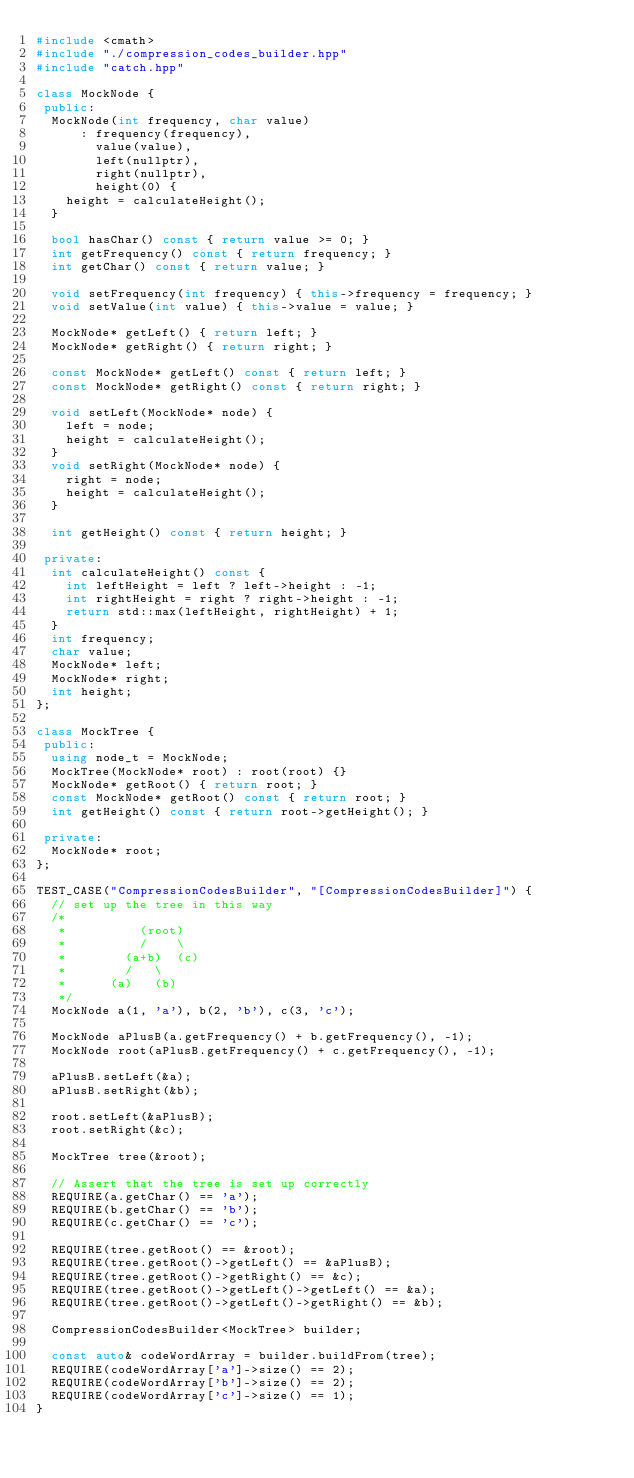<code> <loc_0><loc_0><loc_500><loc_500><_C++_>#include <cmath>
#include "./compression_codes_builder.hpp"
#include "catch.hpp"

class MockNode {
 public:
  MockNode(int frequency, char value)
      : frequency(frequency),
        value(value),
        left(nullptr),
        right(nullptr),
        height(0) {
    height = calculateHeight();
  }

  bool hasChar() const { return value >= 0; }
  int getFrequency() const { return frequency; }
  int getChar() const { return value; }

  void setFrequency(int frequency) { this->frequency = frequency; }
  void setValue(int value) { this->value = value; }

  MockNode* getLeft() { return left; }
  MockNode* getRight() { return right; }

  const MockNode* getLeft() const { return left; }
  const MockNode* getRight() const { return right; }

  void setLeft(MockNode* node) {
    left = node;
    height = calculateHeight();
  }
  void setRight(MockNode* node) {
    right = node;
    height = calculateHeight();
  }

  int getHeight() const { return height; }

 private:
  int calculateHeight() const {
    int leftHeight = left ? left->height : -1;
    int rightHeight = right ? right->height : -1;
    return std::max(leftHeight, rightHeight) + 1;
  }
  int frequency;
  char value;
  MockNode* left;
  MockNode* right;
  int height;
};

class MockTree {
 public:
  using node_t = MockNode;
  MockTree(MockNode* root) : root(root) {}
  MockNode* getRoot() { return root; }
  const MockNode* getRoot() const { return root; }
  int getHeight() const { return root->getHeight(); }

 private:
  MockNode* root;
};

TEST_CASE("CompressionCodesBuilder", "[CompressionCodesBuilder]") {
  // set up the tree in this way
  /*
   *          (root)
   *          /    \
   *        (a+b)  (c)
   *        /   \
   *      (a)   (b)
   */
  MockNode a(1, 'a'), b(2, 'b'), c(3, 'c');

  MockNode aPlusB(a.getFrequency() + b.getFrequency(), -1);
  MockNode root(aPlusB.getFrequency() + c.getFrequency(), -1);

  aPlusB.setLeft(&a);
  aPlusB.setRight(&b);

  root.setLeft(&aPlusB);
  root.setRight(&c);

  MockTree tree(&root);
  
  // Assert that the tree is set up correctly
  REQUIRE(a.getChar() == 'a');
  REQUIRE(b.getChar() == 'b');
  REQUIRE(c.getChar() == 'c');

  REQUIRE(tree.getRoot() == &root);
  REQUIRE(tree.getRoot()->getLeft() == &aPlusB);
  REQUIRE(tree.getRoot()->getRight() == &c);
  REQUIRE(tree.getRoot()->getLeft()->getLeft() == &a);
  REQUIRE(tree.getRoot()->getLeft()->getRight() == &b);
  
  CompressionCodesBuilder<MockTree> builder;

  const auto& codeWordArray = builder.buildFrom(tree);
  REQUIRE(codeWordArray['a']->size() == 2);
  REQUIRE(codeWordArray['b']->size() == 2);
  REQUIRE(codeWordArray['c']->size() == 1);
}
</code> 